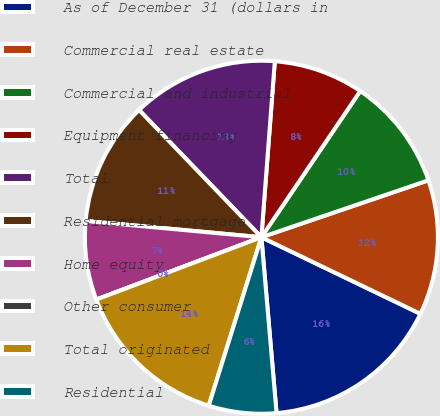Convert chart to OTSL. <chart><loc_0><loc_0><loc_500><loc_500><pie_chart><fcel>As of December 31 (dollars in<fcel>Commercial real estate<fcel>Commercial and industrial<fcel>Equipment financing<fcel>Total<fcel>Residential mortgage<fcel>Home equity<fcel>Other consumer<fcel>Total originated<fcel>Residential<nl><fcel>16.49%<fcel>12.37%<fcel>10.31%<fcel>8.25%<fcel>13.4%<fcel>11.34%<fcel>7.22%<fcel>0.0%<fcel>14.43%<fcel>6.19%<nl></chart> 